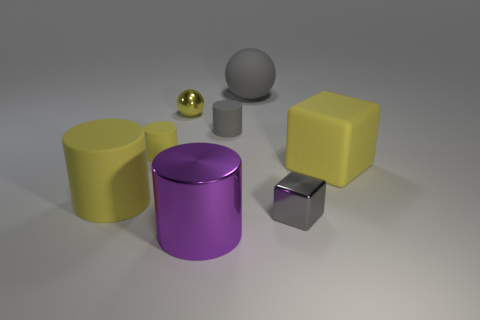What size is the gray object in front of the rubber cylinder that is right of the small yellow rubber thing?
Give a very brief answer. Small. What is the shape of the big gray object?
Keep it short and to the point. Sphere. How many large objects are either yellow objects or gray matte balls?
Offer a very short reply. 3. There is a gray matte object that is the same shape as the purple thing; what is its size?
Make the answer very short. Small. What number of big rubber things are both behind the small yellow rubber cylinder and on the right side of the shiny block?
Give a very brief answer. 0. There is a small yellow matte object; does it have the same shape as the big yellow thing left of the large sphere?
Offer a very short reply. Yes. Are there more tiny things to the right of the large shiny cylinder than tiny yellow balls?
Make the answer very short. Yes. Is the number of tiny objects in front of the small shiny sphere less than the number of small objects?
Offer a terse response. Yes. What number of cylinders have the same color as the matte sphere?
Give a very brief answer. 1. There is a big object that is on the left side of the large gray thing and behind the large purple thing; what is its material?
Your answer should be very brief. Rubber. 